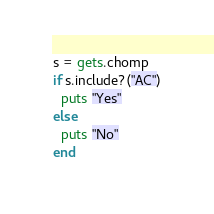<code> <loc_0><loc_0><loc_500><loc_500><_Ruby_>s = gets.chomp
if s.include?("AC")
  puts "Yes"
else
  puts "No"
end</code> 